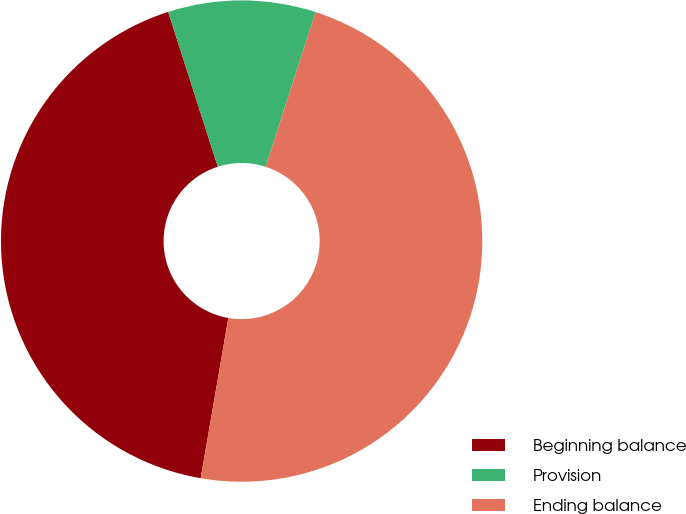<chart> <loc_0><loc_0><loc_500><loc_500><pie_chart><fcel>Beginning balance<fcel>Provision<fcel>Ending balance<nl><fcel>42.34%<fcel>9.91%<fcel>47.75%<nl></chart> 